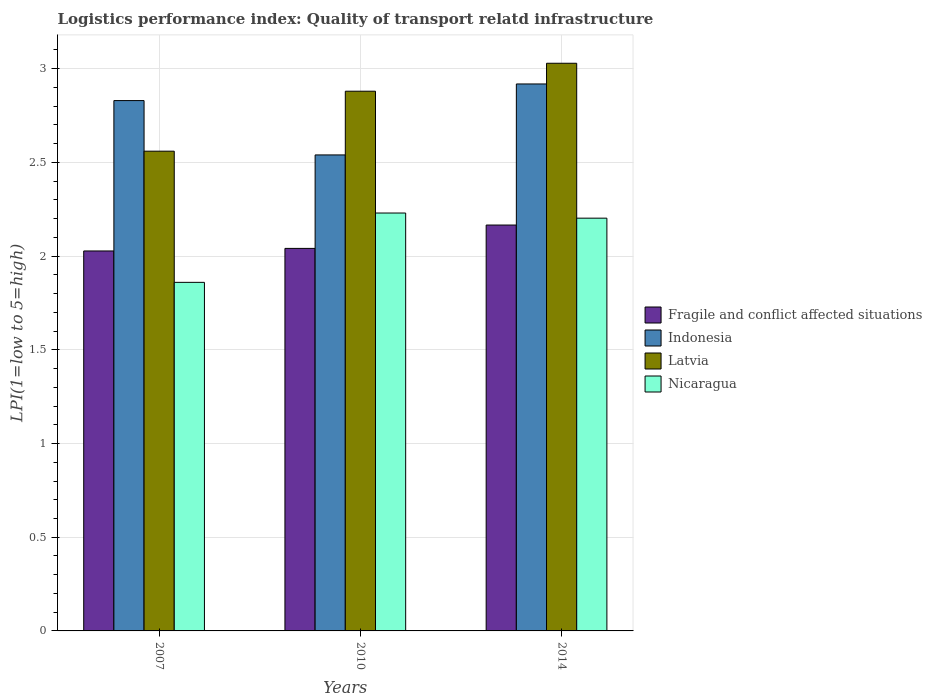How many different coloured bars are there?
Your response must be concise. 4. How many groups of bars are there?
Provide a short and direct response. 3. How many bars are there on the 3rd tick from the right?
Provide a short and direct response. 4. What is the label of the 2nd group of bars from the left?
Provide a short and direct response. 2010. What is the logistics performance index in Fragile and conflict affected situations in 2007?
Your response must be concise. 2.03. Across all years, what is the maximum logistics performance index in Latvia?
Offer a terse response. 3.03. Across all years, what is the minimum logistics performance index in Indonesia?
Provide a short and direct response. 2.54. In which year was the logistics performance index in Fragile and conflict affected situations minimum?
Offer a terse response. 2007. What is the total logistics performance index in Indonesia in the graph?
Your answer should be very brief. 8.29. What is the difference between the logistics performance index in Fragile and conflict affected situations in 2007 and that in 2010?
Offer a terse response. -0.01. What is the difference between the logistics performance index in Nicaragua in 2007 and the logistics performance index in Indonesia in 2010?
Offer a very short reply. -0.68. What is the average logistics performance index in Indonesia per year?
Provide a succinct answer. 2.76. In the year 2007, what is the difference between the logistics performance index in Indonesia and logistics performance index in Latvia?
Keep it short and to the point. 0.27. What is the ratio of the logistics performance index in Fragile and conflict affected situations in 2010 to that in 2014?
Your response must be concise. 0.94. Is the logistics performance index in Latvia in 2010 less than that in 2014?
Your answer should be very brief. Yes. Is the difference between the logistics performance index in Indonesia in 2007 and 2010 greater than the difference between the logistics performance index in Latvia in 2007 and 2010?
Provide a succinct answer. Yes. What is the difference between the highest and the second highest logistics performance index in Indonesia?
Your response must be concise. 0.09. What is the difference between the highest and the lowest logistics performance index in Nicaragua?
Make the answer very short. 0.37. In how many years, is the logistics performance index in Nicaragua greater than the average logistics performance index in Nicaragua taken over all years?
Provide a succinct answer. 2. What does the 2nd bar from the right in 2014 represents?
Provide a succinct answer. Latvia. Is it the case that in every year, the sum of the logistics performance index in Latvia and logistics performance index in Fragile and conflict affected situations is greater than the logistics performance index in Indonesia?
Offer a terse response. Yes. How many bars are there?
Ensure brevity in your answer.  12. Are the values on the major ticks of Y-axis written in scientific E-notation?
Provide a short and direct response. No. Does the graph contain grids?
Provide a succinct answer. Yes. Where does the legend appear in the graph?
Provide a short and direct response. Center right. What is the title of the graph?
Make the answer very short. Logistics performance index: Quality of transport relatd infrastructure. Does "Vanuatu" appear as one of the legend labels in the graph?
Your answer should be compact. No. What is the label or title of the Y-axis?
Your answer should be very brief. LPI(1=low to 5=high). What is the LPI(1=low to 5=high) of Fragile and conflict affected situations in 2007?
Keep it short and to the point. 2.03. What is the LPI(1=low to 5=high) of Indonesia in 2007?
Your response must be concise. 2.83. What is the LPI(1=low to 5=high) in Latvia in 2007?
Offer a terse response. 2.56. What is the LPI(1=low to 5=high) of Nicaragua in 2007?
Provide a succinct answer. 1.86. What is the LPI(1=low to 5=high) of Fragile and conflict affected situations in 2010?
Ensure brevity in your answer.  2.04. What is the LPI(1=low to 5=high) of Indonesia in 2010?
Offer a very short reply. 2.54. What is the LPI(1=low to 5=high) of Latvia in 2010?
Provide a succinct answer. 2.88. What is the LPI(1=low to 5=high) of Nicaragua in 2010?
Provide a succinct answer. 2.23. What is the LPI(1=low to 5=high) in Fragile and conflict affected situations in 2014?
Provide a succinct answer. 2.17. What is the LPI(1=low to 5=high) in Indonesia in 2014?
Offer a terse response. 2.92. What is the LPI(1=low to 5=high) in Latvia in 2014?
Keep it short and to the point. 3.03. What is the LPI(1=low to 5=high) in Nicaragua in 2014?
Give a very brief answer. 2.2. Across all years, what is the maximum LPI(1=low to 5=high) in Fragile and conflict affected situations?
Keep it short and to the point. 2.17. Across all years, what is the maximum LPI(1=low to 5=high) of Indonesia?
Your answer should be very brief. 2.92. Across all years, what is the maximum LPI(1=low to 5=high) of Latvia?
Keep it short and to the point. 3.03. Across all years, what is the maximum LPI(1=low to 5=high) in Nicaragua?
Make the answer very short. 2.23. Across all years, what is the minimum LPI(1=low to 5=high) of Fragile and conflict affected situations?
Your answer should be very brief. 2.03. Across all years, what is the minimum LPI(1=low to 5=high) of Indonesia?
Give a very brief answer. 2.54. Across all years, what is the minimum LPI(1=low to 5=high) of Latvia?
Give a very brief answer. 2.56. Across all years, what is the minimum LPI(1=low to 5=high) in Nicaragua?
Provide a short and direct response. 1.86. What is the total LPI(1=low to 5=high) of Fragile and conflict affected situations in the graph?
Keep it short and to the point. 6.23. What is the total LPI(1=low to 5=high) of Indonesia in the graph?
Make the answer very short. 8.29. What is the total LPI(1=low to 5=high) of Latvia in the graph?
Keep it short and to the point. 8.47. What is the total LPI(1=low to 5=high) in Nicaragua in the graph?
Your answer should be compact. 6.29. What is the difference between the LPI(1=low to 5=high) of Fragile and conflict affected situations in 2007 and that in 2010?
Your response must be concise. -0.01. What is the difference between the LPI(1=low to 5=high) in Indonesia in 2007 and that in 2010?
Make the answer very short. 0.29. What is the difference between the LPI(1=low to 5=high) of Latvia in 2007 and that in 2010?
Your answer should be compact. -0.32. What is the difference between the LPI(1=low to 5=high) in Nicaragua in 2007 and that in 2010?
Give a very brief answer. -0.37. What is the difference between the LPI(1=low to 5=high) of Fragile and conflict affected situations in 2007 and that in 2014?
Ensure brevity in your answer.  -0.14. What is the difference between the LPI(1=low to 5=high) in Indonesia in 2007 and that in 2014?
Give a very brief answer. -0.09. What is the difference between the LPI(1=low to 5=high) in Latvia in 2007 and that in 2014?
Give a very brief answer. -0.47. What is the difference between the LPI(1=low to 5=high) of Nicaragua in 2007 and that in 2014?
Offer a terse response. -0.34. What is the difference between the LPI(1=low to 5=high) of Fragile and conflict affected situations in 2010 and that in 2014?
Provide a short and direct response. -0.12. What is the difference between the LPI(1=low to 5=high) in Indonesia in 2010 and that in 2014?
Your answer should be compact. -0.38. What is the difference between the LPI(1=low to 5=high) in Latvia in 2010 and that in 2014?
Your answer should be compact. -0.15. What is the difference between the LPI(1=low to 5=high) of Nicaragua in 2010 and that in 2014?
Offer a very short reply. 0.03. What is the difference between the LPI(1=low to 5=high) in Fragile and conflict affected situations in 2007 and the LPI(1=low to 5=high) in Indonesia in 2010?
Make the answer very short. -0.51. What is the difference between the LPI(1=low to 5=high) of Fragile and conflict affected situations in 2007 and the LPI(1=low to 5=high) of Latvia in 2010?
Your answer should be compact. -0.85. What is the difference between the LPI(1=low to 5=high) in Fragile and conflict affected situations in 2007 and the LPI(1=low to 5=high) in Nicaragua in 2010?
Keep it short and to the point. -0.2. What is the difference between the LPI(1=low to 5=high) of Indonesia in 2007 and the LPI(1=low to 5=high) of Latvia in 2010?
Keep it short and to the point. -0.05. What is the difference between the LPI(1=low to 5=high) in Latvia in 2007 and the LPI(1=low to 5=high) in Nicaragua in 2010?
Make the answer very short. 0.33. What is the difference between the LPI(1=low to 5=high) in Fragile and conflict affected situations in 2007 and the LPI(1=low to 5=high) in Indonesia in 2014?
Offer a very short reply. -0.89. What is the difference between the LPI(1=low to 5=high) of Fragile and conflict affected situations in 2007 and the LPI(1=low to 5=high) of Latvia in 2014?
Your answer should be very brief. -1. What is the difference between the LPI(1=low to 5=high) of Fragile and conflict affected situations in 2007 and the LPI(1=low to 5=high) of Nicaragua in 2014?
Give a very brief answer. -0.18. What is the difference between the LPI(1=low to 5=high) in Indonesia in 2007 and the LPI(1=low to 5=high) in Latvia in 2014?
Your response must be concise. -0.2. What is the difference between the LPI(1=low to 5=high) in Indonesia in 2007 and the LPI(1=low to 5=high) in Nicaragua in 2014?
Your answer should be very brief. 0.63. What is the difference between the LPI(1=low to 5=high) of Latvia in 2007 and the LPI(1=low to 5=high) of Nicaragua in 2014?
Give a very brief answer. 0.36. What is the difference between the LPI(1=low to 5=high) in Fragile and conflict affected situations in 2010 and the LPI(1=low to 5=high) in Indonesia in 2014?
Provide a short and direct response. -0.88. What is the difference between the LPI(1=low to 5=high) of Fragile and conflict affected situations in 2010 and the LPI(1=low to 5=high) of Latvia in 2014?
Your answer should be compact. -0.99. What is the difference between the LPI(1=low to 5=high) in Fragile and conflict affected situations in 2010 and the LPI(1=low to 5=high) in Nicaragua in 2014?
Offer a very short reply. -0.16. What is the difference between the LPI(1=low to 5=high) in Indonesia in 2010 and the LPI(1=low to 5=high) in Latvia in 2014?
Offer a very short reply. -0.49. What is the difference between the LPI(1=low to 5=high) in Indonesia in 2010 and the LPI(1=low to 5=high) in Nicaragua in 2014?
Offer a very short reply. 0.34. What is the difference between the LPI(1=low to 5=high) in Latvia in 2010 and the LPI(1=low to 5=high) in Nicaragua in 2014?
Your answer should be very brief. 0.68. What is the average LPI(1=low to 5=high) in Fragile and conflict affected situations per year?
Your answer should be very brief. 2.08. What is the average LPI(1=low to 5=high) in Indonesia per year?
Give a very brief answer. 2.76. What is the average LPI(1=low to 5=high) of Latvia per year?
Your response must be concise. 2.82. What is the average LPI(1=low to 5=high) in Nicaragua per year?
Ensure brevity in your answer.  2.1. In the year 2007, what is the difference between the LPI(1=low to 5=high) in Fragile and conflict affected situations and LPI(1=low to 5=high) in Indonesia?
Your response must be concise. -0.8. In the year 2007, what is the difference between the LPI(1=low to 5=high) in Fragile and conflict affected situations and LPI(1=low to 5=high) in Latvia?
Your answer should be very brief. -0.53. In the year 2007, what is the difference between the LPI(1=low to 5=high) in Fragile and conflict affected situations and LPI(1=low to 5=high) in Nicaragua?
Provide a succinct answer. 0.17. In the year 2007, what is the difference between the LPI(1=low to 5=high) in Indonesia and LPI(1=low to 5=high) in Latvia?
Your answer should be very brief. 0.27. In the year 2010, what is the difference between the LPI(1=low to 5=high) of Fragile and conflict affected situations and LPI(1=low to 5=high) of Indonesia?
Provide a short and direct response. -0.5. In the year 2010, what is the difference between the LPI(1=low to 5=high) in Fragile and conflict affected situations and LPI(1=low to 5=high) in Latvia?
Make the answer very short. -0.84. In the year 2010, what is the difference between the LPI(1=low to 5=high) in Fragile and conflict affected situations and LPI(1=low to 5=high) in Nicaragua?
Offer a terse response. -0.19. In the year 2010, what is the difference between the LPI(1=low to 5=high) in Indonesia and LPI(1=low to 5=high) in Latvia?
Offer a terse response. -0.34. In the year 2010, what is the difference between the LPI(1=low to 5=high) in Indonesia and LPI(1=low to 5=high) in Nicaragua?
Provide a short and direct response. 0.31. In the year 2010, what is the difference between the LPI(1=low to 5=high) in Latvia and LPI(1=low to 5=high) in Nicaragua?
Your answer should be very brief. 0.65. In the year 2014, what is the difference between the LPI(1=low to 5=high) of Fragile and conflict affected situations and LPI(1=low to 5=high) of Indonesia?
Your answer should be very brief. -0.75. In the year 2014, what is the difference between the LPI(1=low to 5=high) in Fragile and conflict affected situations and LPI(1=low to 5=high) in Latvia?
Offer a terse response. -0.86. In the year 2014, what is the difference between the LPI(1=low to 5=high) of Fragile and conflict affected situations and LPI(1=low to 5=high) of Nicaragua?
Make the answer very short. -0.04. In the year 2014, what is the difference between the LPI(1=low to 5=high) of Indonesia and LPI(1=low to 5=high) of Latvia?
Give a very brief answer. -0.11. In the year 2014, what is the difference between the LPI(1=low to 5=high) in Indonesia and LPI(1=low to 5=high) in Nicaragua?
Ensure brevity in your answer.  0.72. In the year 2014, what is the difference between the LPI(1=low to 5=high) in Latvia and LPI(1=low to 5=high) in Nicaragua?
Your answer should be compact. 0.83. What is the ratio of the LPI(1=low to 5=high) of Indonesia in 2007 to that in 2010?
Offer a very short reply. 1.11. What is the ratio of the LPI(1=low to 5=high) of Nicaragua in 2007 to that in 2010?
Provide a succinct answer. 0.83. What is the ratio of the LPI(1=low to 5=high) in Fragile and conflict affected situations in 2007 to that in 2014?
Offer a very short reply. 0.94. What is the ratio of the LPI(1=low to 5=high) in Indonesia in 2007 to that in 2014?
Provide a succinct answer. 0.97. What is the ratio of the LPI(1=low to 5=high) of Latvia in 2007 to that in 2014?
Give a very brief answer. 0.85. What is the ratio of the LPI(1=low to 5=high) of Nicaragua in 2007 to that in 2014?
Your response must be concise. 0.84. What is the ratio of the LPI(1=low to 5=high) of Fragile and conflict affected situations in 2010 to that in 2014?
Your answer should be compact. 0.94. What is the ratio of the LPI(1=low to 5=high) in Indonesia in 2010 to that in 2014?
Give a very brief answer. 0.87. What is the ratio of the LPI(1=low to 5=high) in Latvia in 2010 to that in 2014?
Give a very brief answer. 0.95. What is the ratio of the LPI(1=low to 5=high) of Nicaragua in 2010 to that in 2014?
Your answer should be compact. 1.01. What is the difference between the highest and the second highest LPI(1=low to 5=high) of Fragile and conflict affected situations?
Ensure brevity in your answer.  0.12. What is the difference between the highest and the second highest LPI(1=low to 5=high) of Indonesia?
Keep it short and to the point. 0.09. What is the difference between the highest and the second highest LPI(1=low to 5=high) of Latvia?
Provide a short and direct response. 0.15. What is the difference between the highest and the second highest LPI(1=low to 5=high) of Nicaragua?
Offer a very short reply. 0.03. What is the difference between the highest and the lowest LPI(1=low to 5=high) of Fragile and conflict affected situations?
Give a very brief answer. 0.14. What is the difference between the highest and the lowest LPI(1=low to 5=high) in Indonesia?
Offer a very short reply. 0.38. What is the difference between the highest and the lowest LPI(1=low to 5=high) of Latvia?
Your answer should be compact. 0.47. What is the difference between the highest and the lowest LPI(1=low to 5=high) in Nicaragua?
Offer a terse response. 0.37. 